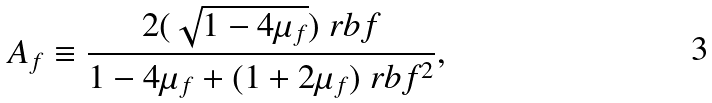Convert formula to latex. <formula><loc_0><loc_0><loc_500><loc_500>A _ { f } \equiv \frac { 2 ( \sqrt { 1 - 4 \mu _ { f } } ) \ r b f } { 1 - 4 \mu _ { f } + ( 1 + 2 \mu _ { f } ) \ r b f ^ { 2 } } ,</formula> 